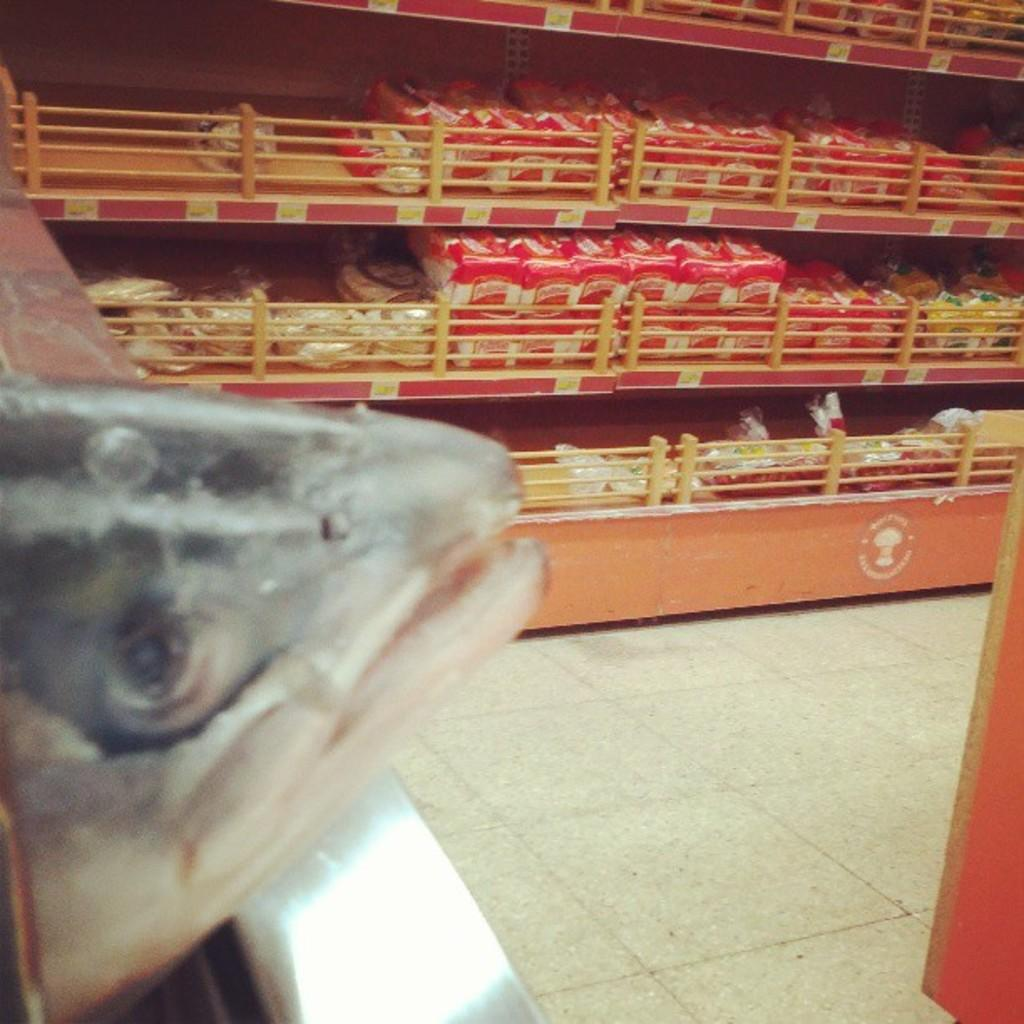What type of animal can be seen on the left side of the image? There is a fish on the left side of the image. What else is visible in the image besides the fish? There are racks with groceries in the image. Can you see a plane in the image? No, there is no plane present in the image. Is there an argument happening between the fish and the groceries in the image? No, there is no argument depicted in the image. 